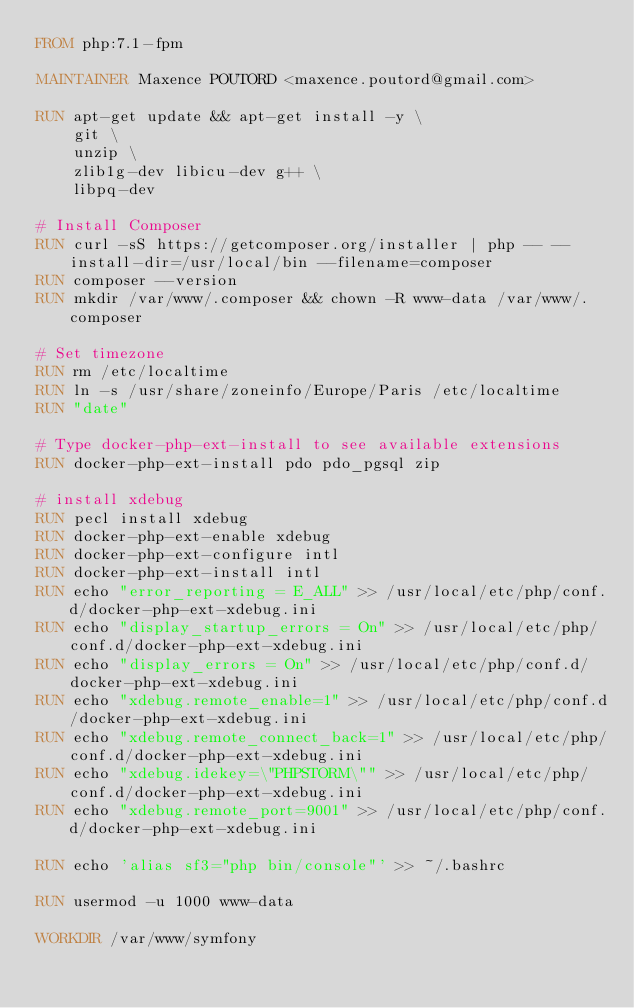Convert code to text. <code><loc_0><loc_0><loc_500><loc_500><_Dockerfile_>FROM php:7.1-fpm

MAINTAINER Maxence POUTORD <maxence.poutord@gmail.com>

RUN apt-get update && apt-get install -y \
    git \
    unzip \
    zlib1g-dev libicu-dev g++ \
    libpq-dev

# Install Composer
RUN curl -sS https://getcomposer.org/installer | php -- --install-dir=/usr/local/bin --filename=composer
RUN composer --version
RUN mkdir /var/www/.composer && chown -R www-data /var/www/.composer

# Set timezone
RUN rm /etc/localtime
RUN ln -s /usr/share/zoneinfo/Europe/Paris /etc/localtime
RUN "date"

# Type docker-php-ext-install to see available extensions
RUN docker-php-ext-install pdo pdo_pgsql zip

# install xdebug
RUN pecl install xdebug
RUN docker-php-ext-enable xdebug
RUN docker-php-ext-configure intl
RUN docker-php-ext-install intl
RUN echo "error_reporting = E_ALL" >> /usr/local/etc/php/conf.d/docker-php-ext-xdebug.ini
RUN echo "display_startup_errors = On" >> /usr/local/etc/php/conf.d/docker-php-ext-xdebug.ini
RUN echo "display_errors = On" >> /usr/local/etc/php/conf.d/docker-php-ext-xdebug.ini
RUN echo "xdebug.remote_enable=1" >> /usr/local/etc/php/conf.d/docker-php-ext-xdebug.ini
RUN echo "xdebug.remote_connect_back=1" >> /usr/local/etc/php/conf.d/docker-php-ext-xdebug.ini
RUN echo "xdebug.idekey=\"PHPSTORM\"" >> /usr/local/etc/php/conf.d/docker-php-ext-xdebug.ini
RUN echo "xdebug.remote_port=9001" >> /usr/local/etc/php/conf.d/docker-php-ext-xdebug.ini

RUN echo 'alias sf3="php bin/console"' >> ~/.bashrc

RUN usermod -u 1000 www-data

WORKDIR /var/www/symfony</code> 